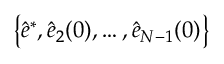<formula> <loc_0><loc_0><loc_500><loc_500>\left \{ \hat { e } ^ { * } , \hat { e } _ { 2 } ( 0 ) , \dots , \hat { e } _ { N - 1 } ( 0 ) \right \}</formula> 